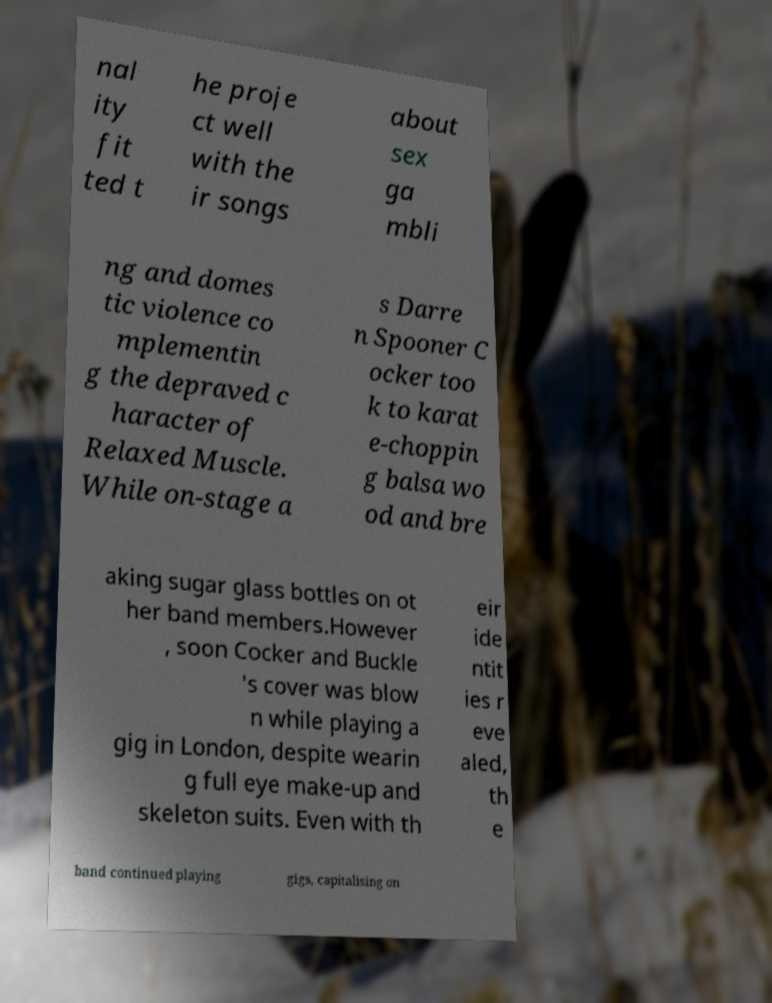Can you accurately transcribe the text from the provided image for me? nal ity fit ted t he proje ct well with the ir songs about sex ga mbli ng and domes tic violence co mplementin g the depraved c haracter of Relaxed Muscle. While on-stage a s Darre n Spooner C ocker too k to karat e-choppin g balsa wo od and bre aking sugar glass bottles on ot her band members.However , soon Cocker and Buckle 's cover was blow n while playing a gig in London, despite wearin g full eye make-up and skeleton suits. Even with th eir ide ntit ies r eve aled, th e band continued playing gigs, capitalising on 